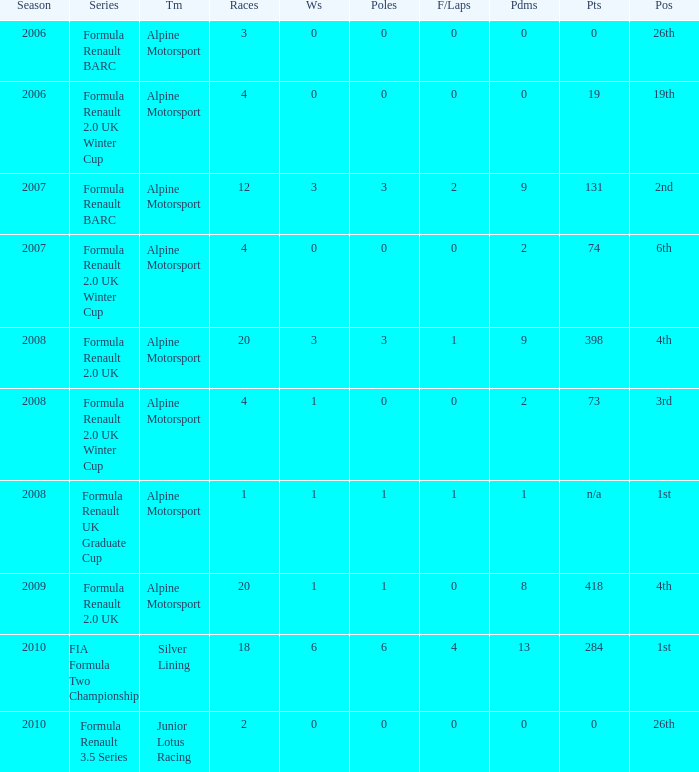What was the earliest season where podium was 9? 2007.0. 